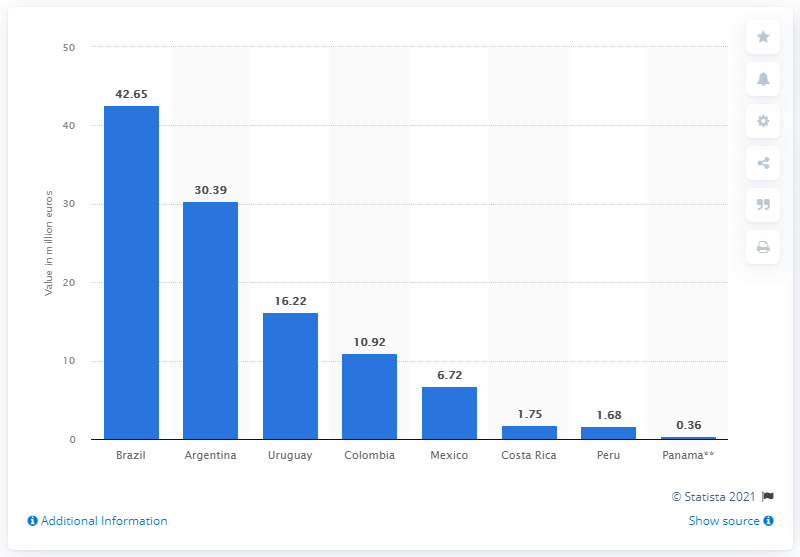Give some essential details in this illustration. Argentina's average market value by player was 30.39. The average market value of the Brazilian soccer team was 42.65. 